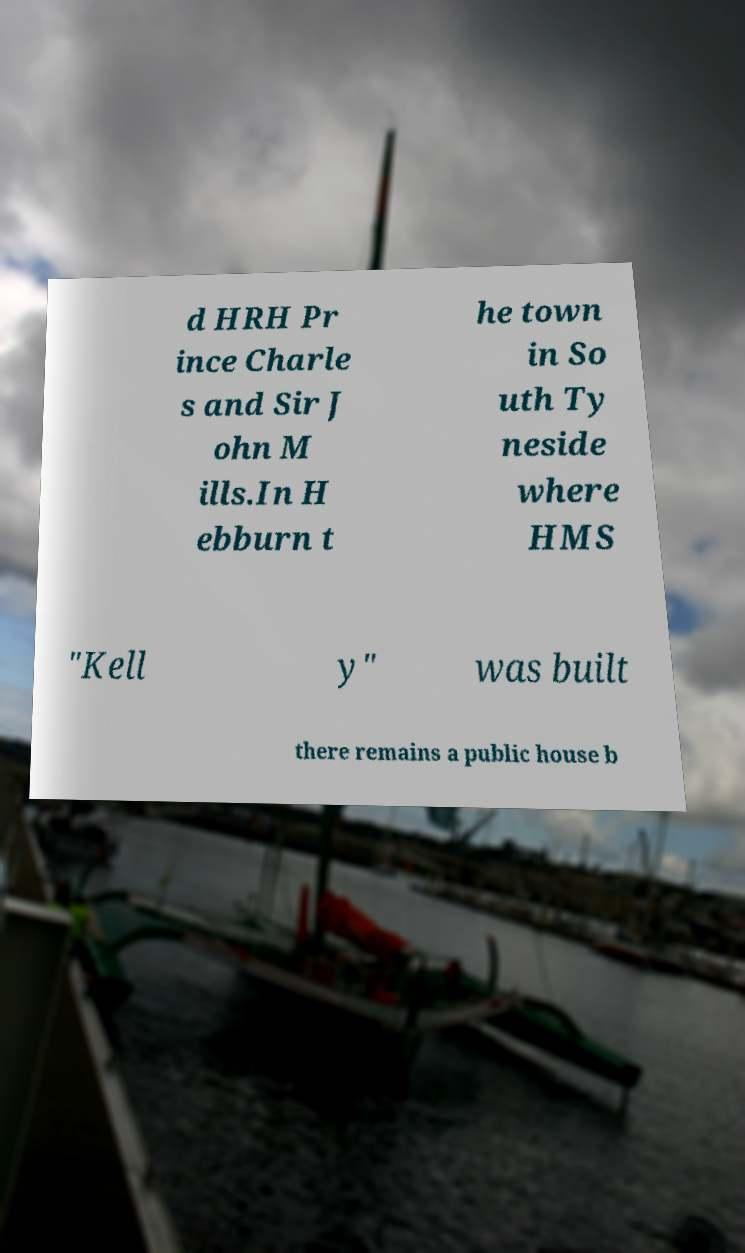Can you accurately transcribe the text from the provided image for me? d HRH Pr ince Charle s and Sir J ohn M ills.In H ebburn t he town in So uth Ty neside where HMS "Kell y" was built there remains a public house b 